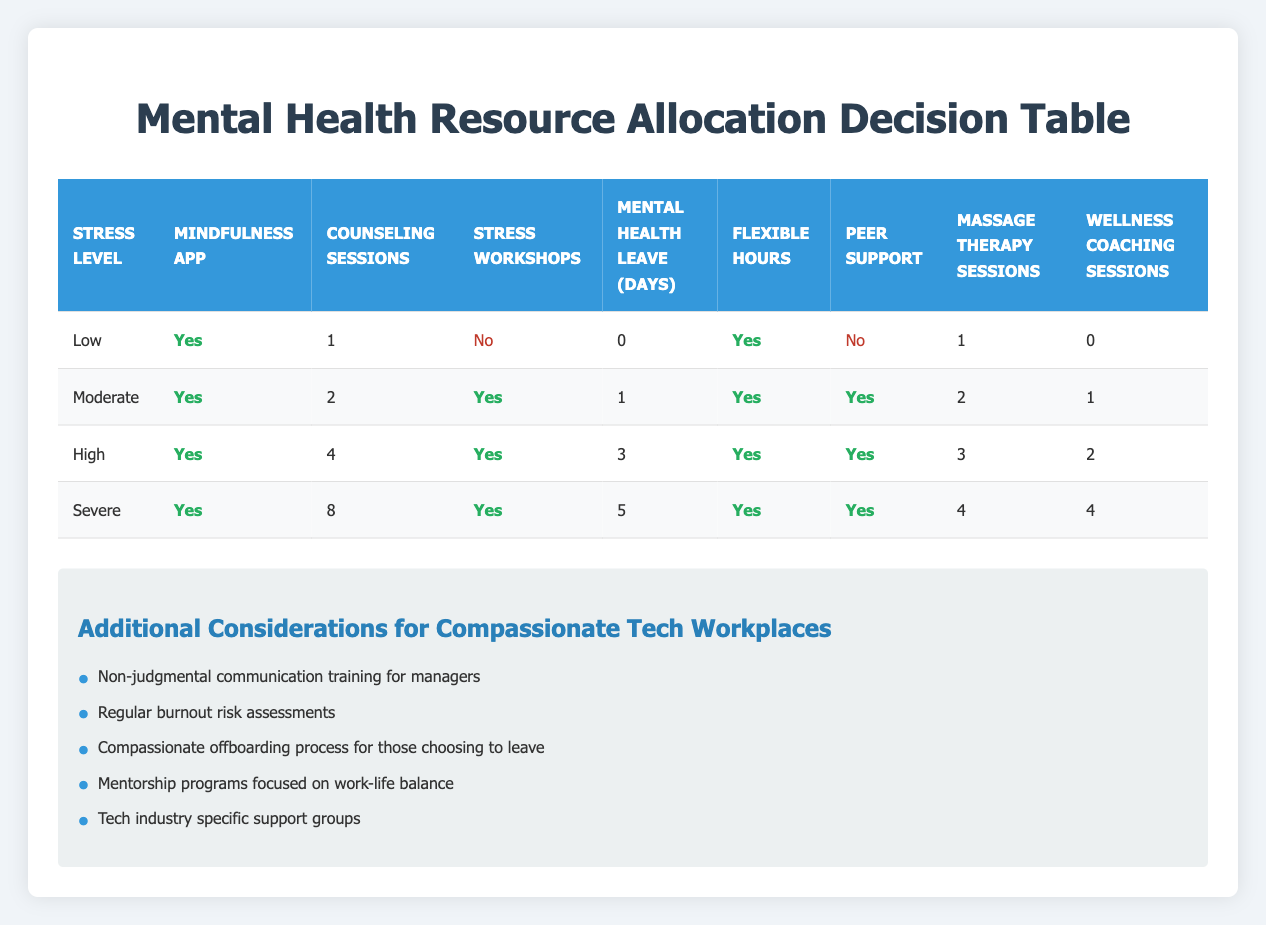What resources are allocated for Moderate stress levels? For Moderate stress levels, the resources allocated are: Mindfulness app (Yes), Counseling sessions (2), Stress workshops (Yes), Mental health leave (1 day), Flexible hours (Yes), Peer support (Yes), Massage therapy sessions (2), Wellness coaching sessions (1).
Answer: Mindfulness app, Counseling sessions (2), Stress workshops, Mental health leave (1), Flexible hours, Peer support, Massage therapy sessions (2), Wellness coaching sessions (1) Is there a mindfulness app subscription for High stress levels? According to the table, the resource for High stress levels has a mindfulness app allocated, indicated as Yes.
Answer: Yes How many counseling sessions are provided for Severe stress levels? The table shows that for Severe stress levels, 8 counseling sessions are allocated.
Answer: 8 What is the total number of leave days allocated for High stress levels? For High stress levels, the allocated mental health leave is 3 days, as stated in the table.
Answer: 3 Which stress level has the highest number of massage therapy sessions? The table indicates that Severe stress levels have the highest number of massage therapy sessions, which is 4.
Answer: Severe Are stress management workshops included in Low stress resources? Referring to the table, for Low stress levels, stress management workshops are not included as indicated by the No.
Answer: No What is the difference in the number of counseling sessions between Moderate and High stress levels? For Moderate stress levels, there are 2 counseling sessions allocated, while for High stress levels, there are 4 counseling sessions. The difference is 4 - 2 = 2.
Answer: 2 How many total resources are provided for Severe stress levels? The resources allocated for Severe stress levels include: Mindfulness app, Counseling sessions (8), Stress workshops, Mental health leave (5), Flexible hours, Peer support, Massage therapy sessions (4), Wellness coaching sessions (4). Counting these gives a total of 8 resources.
Answer: 8 Which stress level provides the least amount of mental health leave? The table shows that for Low stress levels, there are 0 mental health leave days allocated, which is the least compared to other stress levels.
Answer: Low 